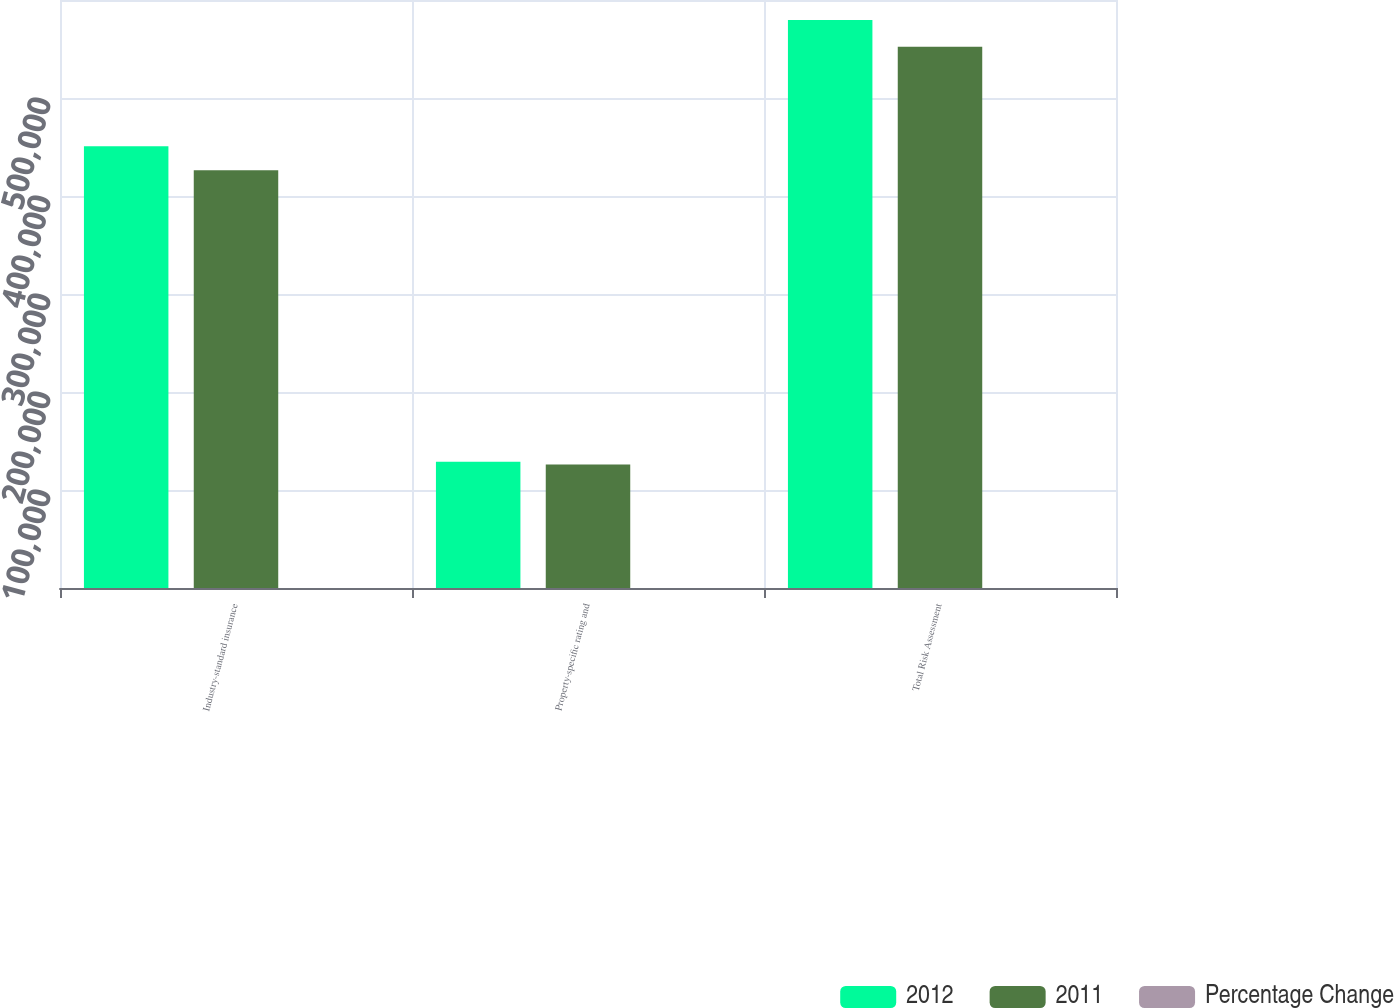<chart> <loc_0><loc_0><loc_500><loc_500><stacked_bar_chart><ecel><fcel>Industry-standard insurance<fcel>Property-specific rating and<fcel>Total Risk Assessment<nl><fcel>2012<fcel>450646<fcel>128860<fcel>579506<nl><fcel>2011<fcel>426228<fcel>126065<fcel>552293<nl><fcel>Percentage Change<fcel>5.7<fcel>2.2<fcel>4.9<nl></chart> 